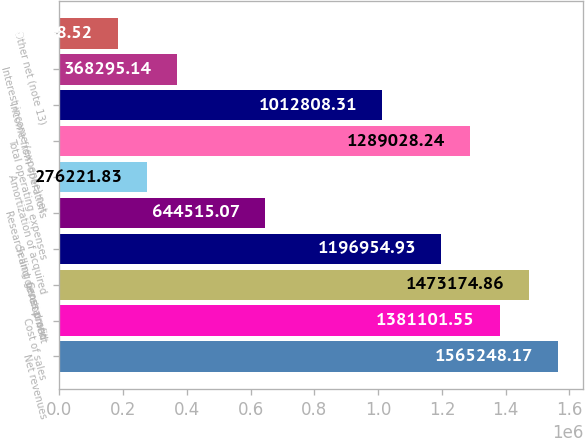Convert chart to OTSL. <chart><loc_0><loc_0><loc_500><loc_500><bar_chart><fcel>Net revenues<fcel>Cost of sales<fcel>Gross profit<fcel>Selling general and<fcel>Research and development<fcel>Amortization of acquired<fcel>Total operating expenses<fcel>Income from operations<fcel>Interest income (expense) net<fcel>Other net (note 13)<nl><fcel>1.56525e+06<fcel>1.3811e+06<fcel>1.47317e+06<fcel>1.19695e+06<fcel>644515<fcel>276222<fcel>1.28903e+06<fcel>1.01281e+06<fcel>368295<fcel>184149<nl></chart> 